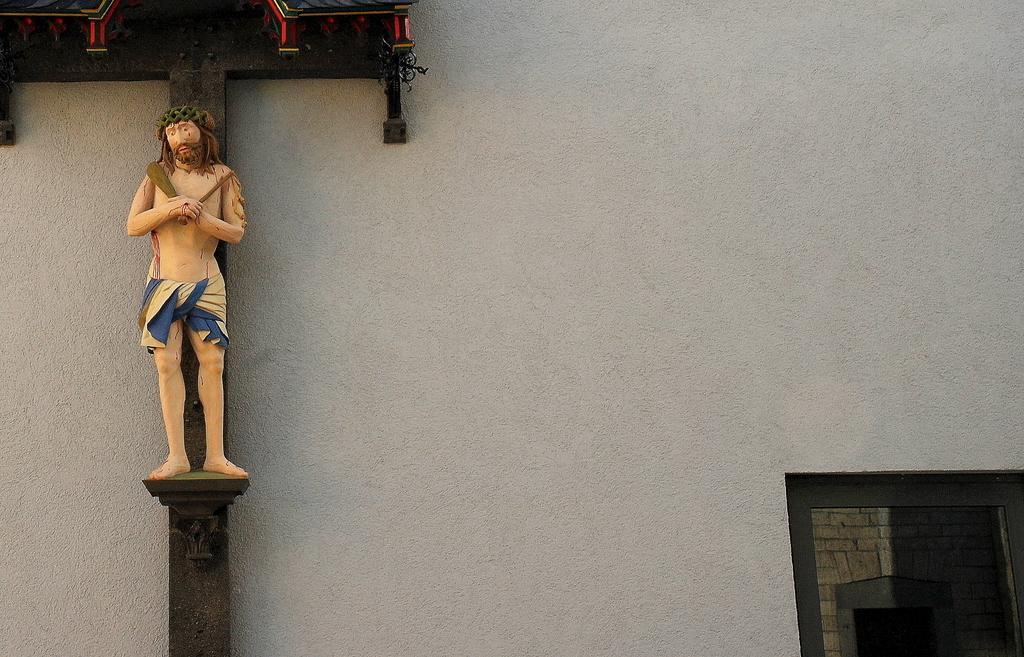Please provide a concise description of this image. In this image we can see statue of a person on the platform which is on the wall. At the bottom right corner of the image we can see a window. On the window glass we can see the reflection. 